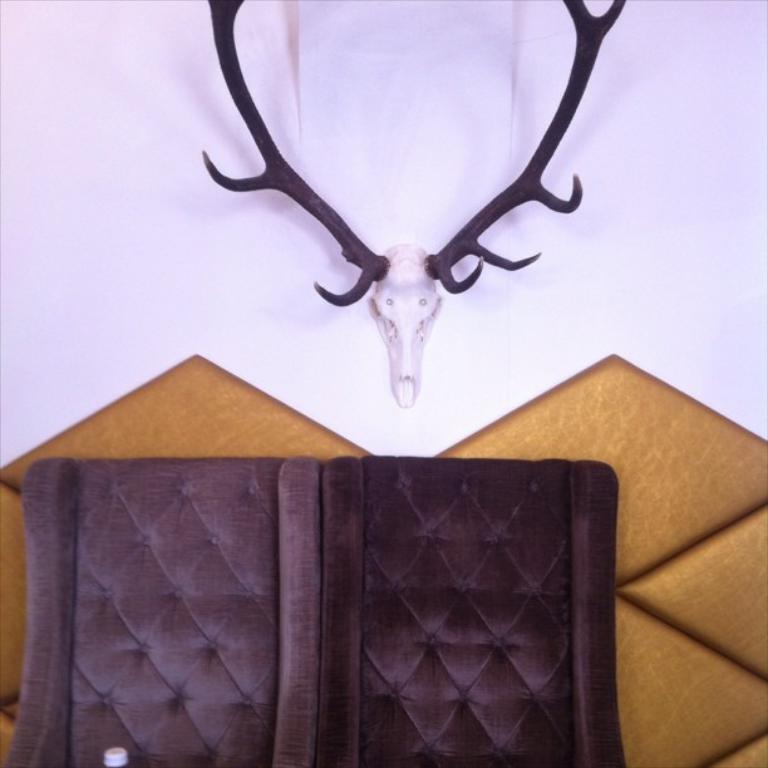How many chairs are visible in the image? There are 2 brown chairs in the image. What is the color of the chairs? The chairs are brown. What can be seen on the wall in the background of the image? There is a deer head mounted on a wall in the background of the image. What type of school is depicted in the image? There is no school present in the image; it features 2 brown chairs and a deer head mounted on a wall. 